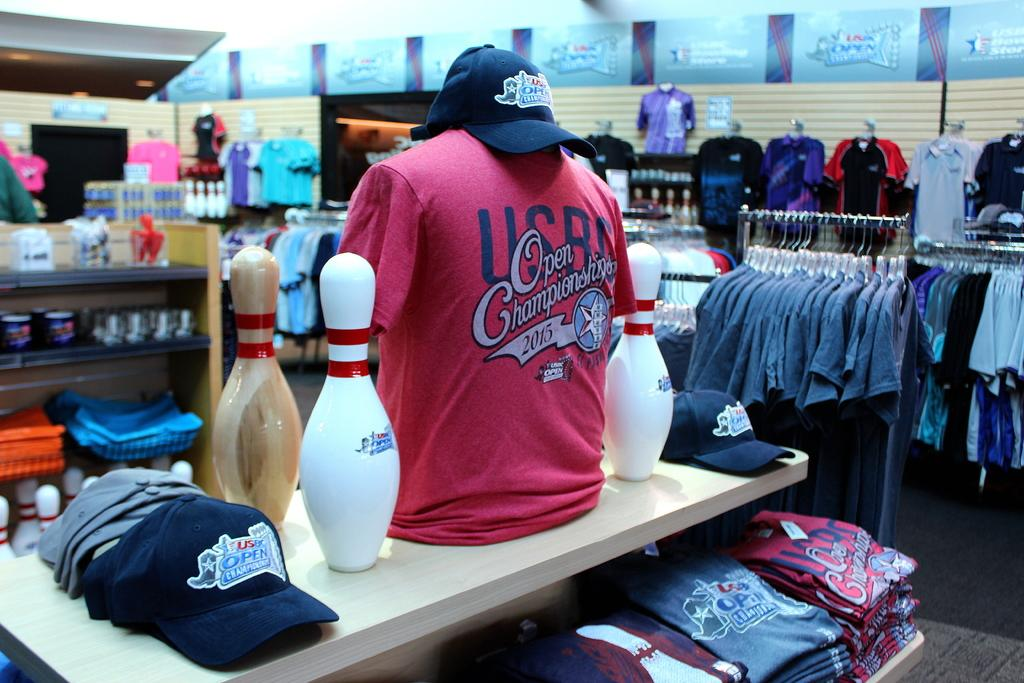What is being hung up in the image? There are clothes hanged in the image. What type of headwear can be seen in the image? There are caps in the image. What figures are present in the image? There are mannequins in the image. What sport-related objects are visible in the image? There are bowling pins in the image. What is visible in the background of the image? There is a wall in the background of the image. How many cows are balancing on the bowling pins in the image? There are no cows or blades present in the image; it features clothes, caps, mannequins, bowling pins, and a wall in the background. 